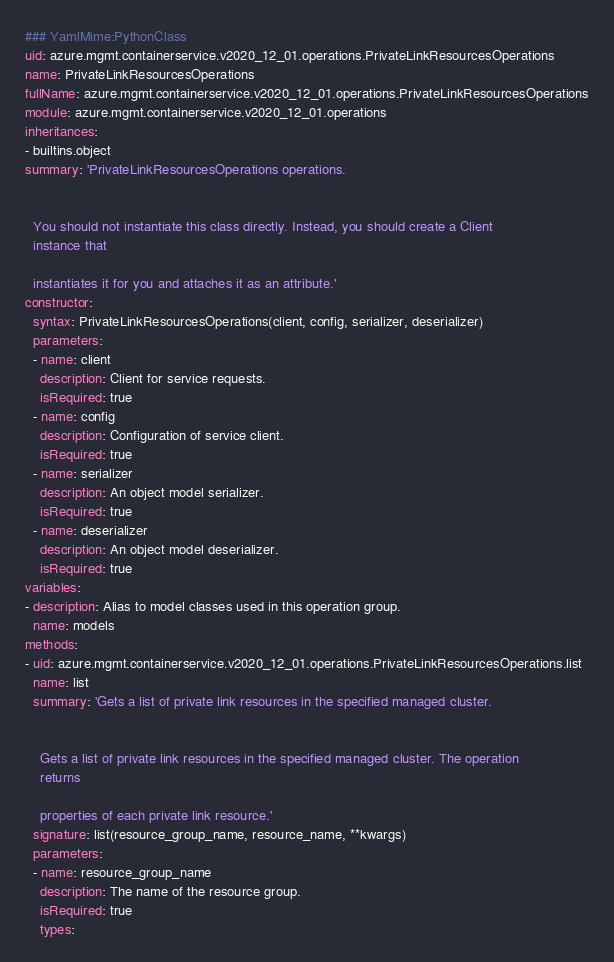Convert code to text. <code><loc_0><loc_0><loc_500><loc_500><_YAML_>### YamlMime:PythonClass
uid: azure.mgmt.containerservice.v2020_12_01.operations.PrivateLinkResourcesOperations
name: PrivateLinkResourcesOperations
fullName: azure.mgmt.containerservice.v2020_12_01.operations.PrivateLinkResourcesOperations
module: azure.mgmt.containerservice.v2020_12_01.operations
inheritances:
- builtins.object
summary: 'PrivateLinkResourcesOperations operations.


  You should not instantiate this class directly. Instead, you should create a Client
  instance that

  instantiates it for you and attaches it as an attribute.'
constructor:
  syntax: PrivateLinkResourcesOperations(client, config, serializer, deserializer)
  parameters:
  - name: client
    description: Client for service requests.
    isRequired: true
  - name: config
    description: Configuration of service client.
    isRequired: true
  - name: serializer
    description: An object model serializer.
    isRequired: true
  - name: deserializer
    description: An object model deserializer.
    isRequired: true
variables:
- description: Alias to model classes used in this operation group.
  name: models
methods:
- uid: azure.mgmt.containerservice.v2020_12_01.operations.PrivateLinkResourcesOperations.list
  name: list
  summary: 'Gets a list of private link resources in the specified managed cluster.


    Gets a list of private link resources in the specified managed cluster. The operation
    returns

    properties of each private link resource.'
  signature: list(resource_group_name, resource_name, **kwargs)
  parameters:
  - name: resource_group_name
    description: The name of the resource group.
    isRequired: true
    types:</code> 